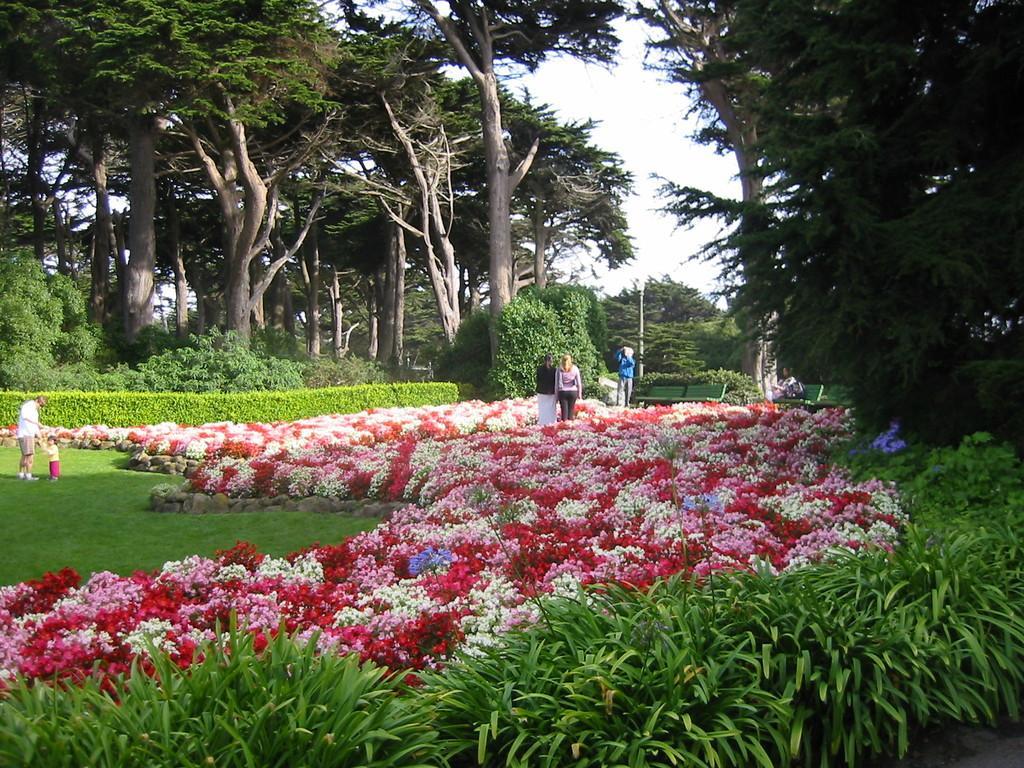In one or two sentences, can you explain what this image depicts? In this image there is a beautiful garden of flowers, plants and trees also there are some people standing on the grass. 